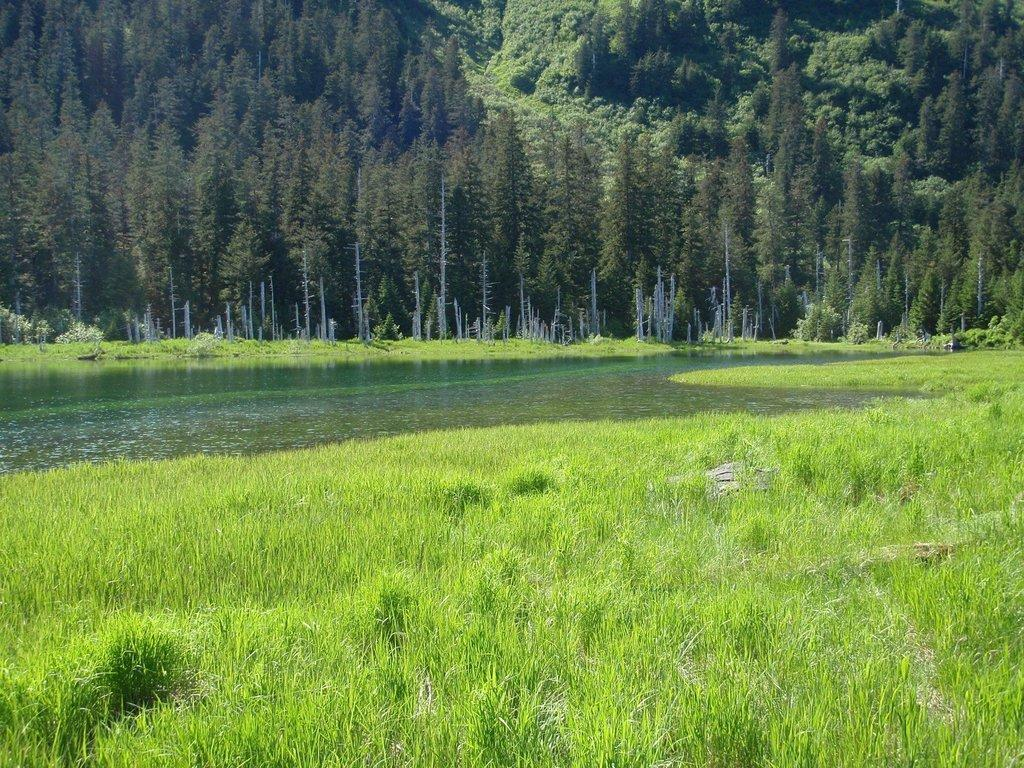What type of natural environment is visible in the image? There is grass visible in the image. What can be seen in the middle of the image? There is water in the middle of the image. What type of vegetation is visible at the top of the image? There are trees at the top of the image. What type of current can be seen flowing through the plate in the image? There is no plate present in the image, and therefore no current flowing through it. 